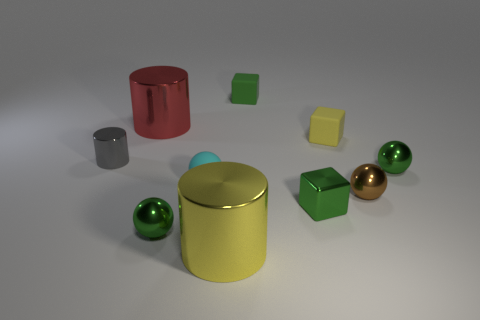There is a tiny brown thing that is the same shape as the cyan rubber object; what is it made of?
Offer a terse response. Metal. There is a matte thing that is on the left side of the small green rubber object; is it the same color as the small cylinder?
Provide a short and direct response. No. Are the cyan object and the green ball that is right of the small metallic cube made of the same material?
Your response must be concise. No. There is a big object that is left of the large yellow cylinder; what shape is it?
Your response must be concise. Cylinder. How many other objects are there of the same material as the tiny brown thing?
Your answer should be very brief. 6. What size is the yellow shiny thing?
Ensure brevity in your answer.  Large. What number of other things are there of the same color as the tiny shiny cylinder?
Offer a terse response. 0. There is a shiny object that is both to the right of the small green rubber cube and in front of the small brown thing; what is its color?
Offer a very short reply. Green. How many small brown objects are there?
Your response must be concise. 1. Do the red thing and the gray cylinder have the same material?
Give a very brief answer. Yes. 